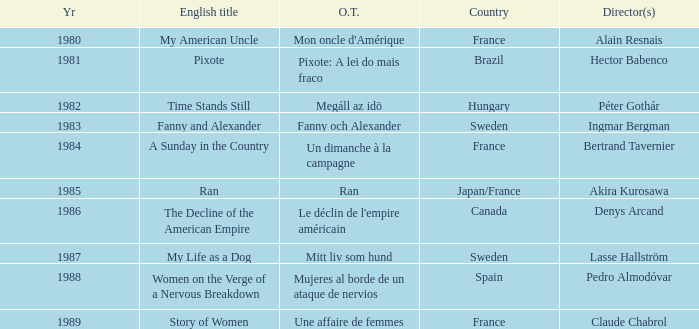What was the original title that was directed by Alain Resnais in France before 1986? Mon oncle d'Amérique. 